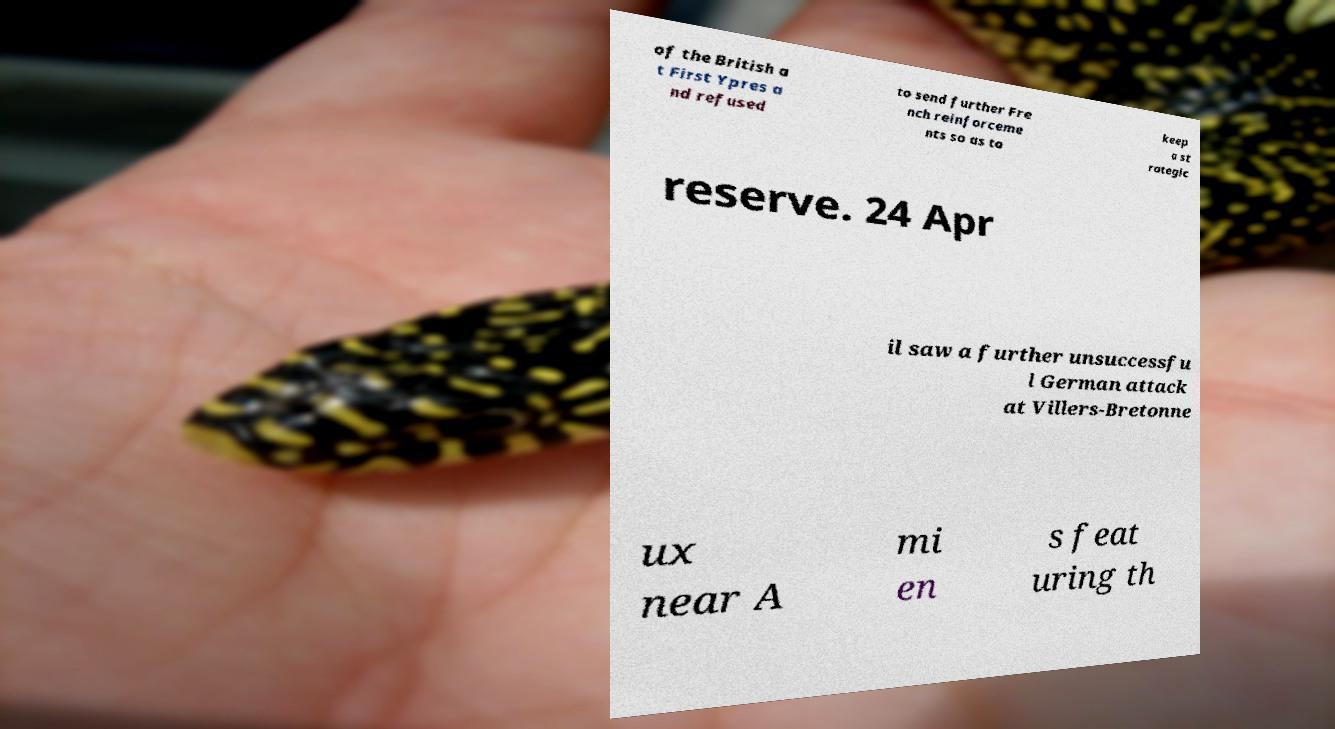For documentation purposes, I need the text within this image transcribed. Could you provide that? of the British a t First Ypres a nd refused to send further Fre nch reinforceme nts so as to keep a st rategic reserve. 24 Apr il saw a further unsuccessfu l German attack at Villers-Bretonne ux near A mi en s feat uring th 